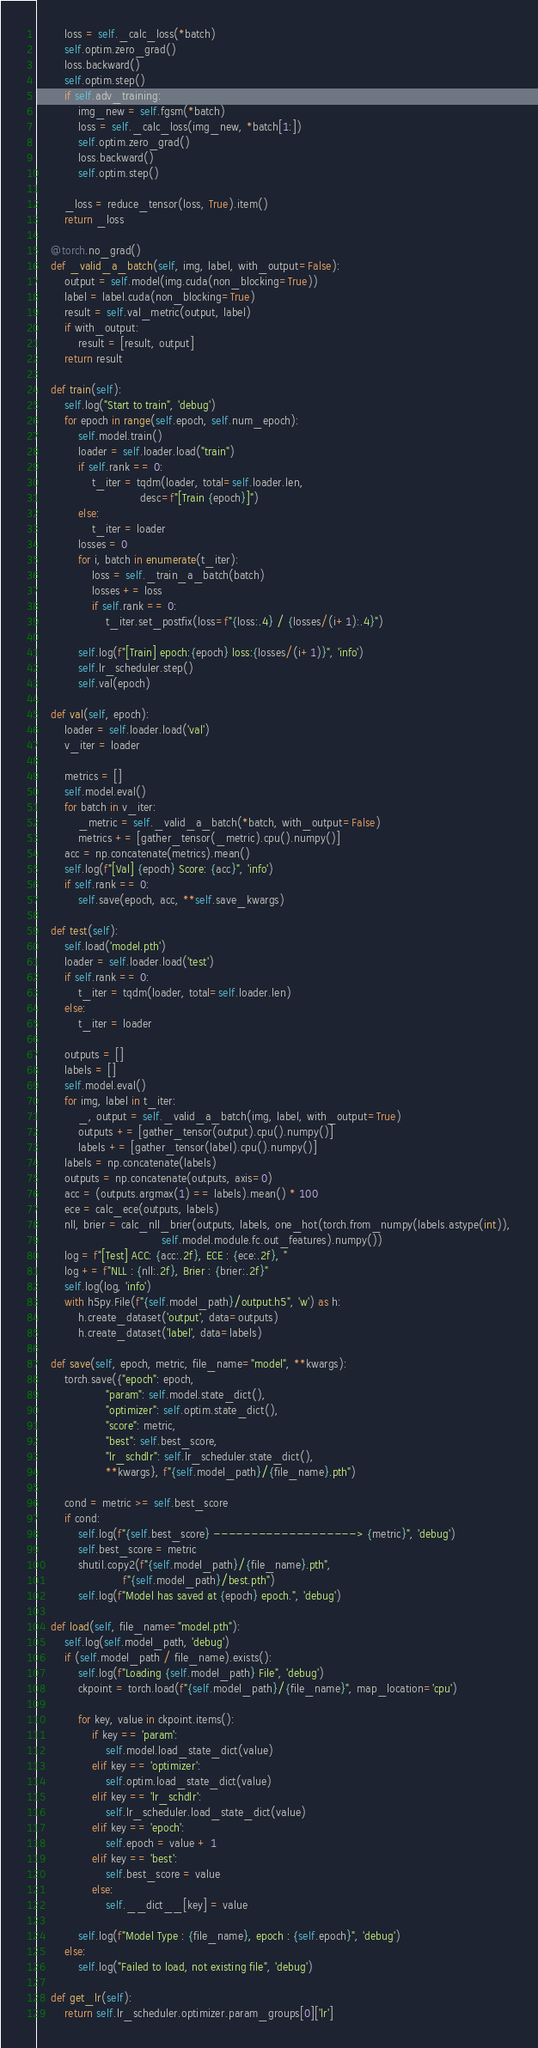<code> <loc_0><loc_0><loc_500><loc_500><_Python_>        loss = self._calc_loss(*batch)
        self.optim.zero_grad()
        loss.backward()
        self.optim.step()
        if self.adv_training:
            img_new = self.fgsm(*batch)
            loss = self._calc_loss(img_new, *batch[1:])
            self.optim.zero_grad()
            loss.backward()
            self.optim.step()

        _loss = reduce_tensor(loss, True).item()
        return _loss

    @torch.no_grad()
    def _valid_a_batch(self, img, label, with_output=False):
        output = self.model(img.cuda(non_blocking=True))
        label = label.cuda(non_blocking=True)
        result = self.val_metric(output, label)
        if with_output:
            result = [result, output]
        return result

    def train(self):
        self.log("Start to train", 'debug')
        for epoch in range(self.epoch, self.num_epoch):
            self.model.train()
            loader = self.loader.load("train")
            if self.rank == 0:
                t_iter = tqdm(loader, total=self.loader.len,
                              desc=f"[Train {epoch}]")
            else:
                t_iter = loader
            losses = 0
            for i, batch in enumerate(t_iter):
                loss = self._train_a_batch(batch)
                losses += loss
                if self.rank == 0:
                    t_iter.set_postfix(loss=f"{loss:.4} / {losses/(i+1):.4}")

            self.log(f"[Train] epoch:{epoch} loss:{losses/(i+1)}", 'info')
            self.lr_scheduler.step()
            self.val(epoch)

    def val(self, epoch):
        loader = self.loader.load('val')
        v_iter = loader

        metrics = []
        self.model.eval()
        for batch in v_iter:
            _metric = self._valid_a_batch(*batch, with_output=False)
            metrics += [gather_tensor(_metric).cpu().numpy()]
        acc = np.concatenate(metrics).mean()
        self.log(f"[Val] {epoch} Score: {acc}", 'info')
        if self.rank == 0:
            self.save(epoch, acc, **self.save_kwargs)

    def test(self):
        self.load('model.pth')
        loader = self.loader.load('test')
        if self.rank == 0:
            t_iter = tqdm(loader, total=self.loader.len)
        else:
            t_iter = loader

        outputs = []
        labels = []
        self.model.eval()
        for img, label in t_iter:
            _, output = self._valid_a_batch(img, label, with_output=True)
            outputs += [gather_tensor(output).cpu().numpy()]
            labels += [gather_tensor(label).cpu().numpy()]
        labels = np.concatenate(labels)
        outputs = np.concatenate(outputs, axis=0)
        acc = (outputs.argmax(1) == labels).mean() * 100
        ece = calc_ece(outputs, labels)
        nll, brier = calc_nll_brier(outputs, labels, one_hot(torch.from_numpy(labels.astype(int)),
                                    self.model.module.fc.out_features).numpy())
        log = f"[Test] ACC: {acc:.2f}, ECE : {ece:.2f}, "
        log += f"NLL : {nll:.2f}, Brier : {brier:.2f}"
        self.log(log, 'info')
        with h5py.File(f"{self.model_path}/output.h5", 'w') as h:
            h.create_dataset('output', data=outputs)
            h.create_dataset('label', data=labels)

    def save(self, epoch, metric, file_name="model", **kwargs):
        torch.save({"epoch": epoch,
                    "param": self.model.state_dict(),
                    "optimizer": self.optim.state_dict(),
                    "score": metric,
                    "best": self.best_score,
                    "lr_schdlr": self.lr_scheduler.state_dict(),
                    **kwargs}, f"{self.model_path}/{file_name}.pth")

        cond = metric >= self.best_score
        if cond:
            self.log(f"{self.best_score} -------------------> {metric}", 'debug')
            self.best_score = metric
            shutil.copy2(f"{self.model_path}/{file_name}.pth",
                         f"{self.model_path}/best.pth")
            self.log(f"Model has saved at {epoch} epoch.", 'debug')

    def load(self, file_name="model.pth"):
        self.log(self.model_path, 'debug')
        if (self.model_path / file_name).exists():
            self.log(f"Loading {self.model_path} File", 'debug')
            ckpoint = torch.load(f"{self.model_path}/{file_name}", map_location='cpu')

            for key, value in ckpoint.items():
                if key == 'param':
                    self.model.load_state_dict(value)
                elif key == 'optimizer':
                    self.optim.load_state_dict(value)
                elif key == 'lr_schdlr':
                    self.lr_scheduler.load_state_dict(value)
                elif key == 'epoch':
                    self.epoch = value + 1
                elif key == 'best':
                    self.best_score = value
                else:
                    self.__dict__[key] = value

            self.log(f"Model Type : {file_name}, epoch : {self.epoch}", 'debug')
        else:
            self.log("Failed to load, not existing file", 'debug')

    def get_lr(self):
        return self.lr_scheduler.optimizer.param_groups[0]['lr']
</code> 